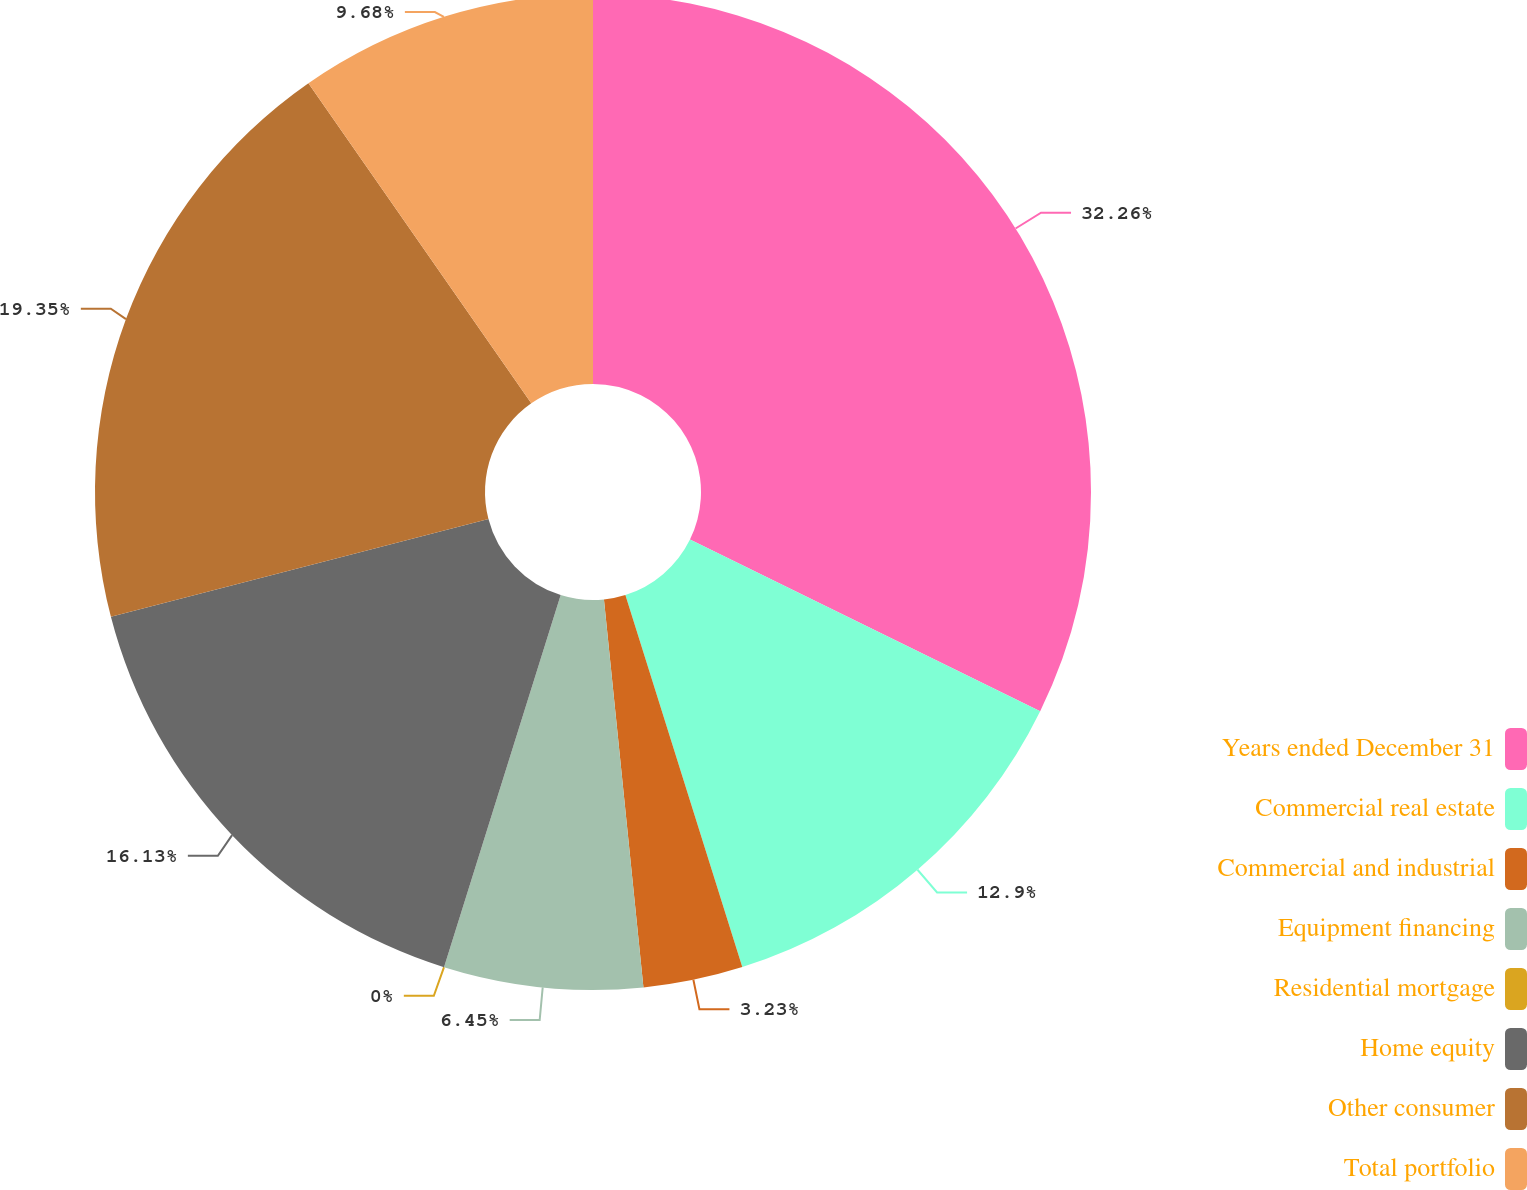Convert chart to OTSL. <chart><loc_0><loc_0><loc_500><loc_500><pie_chart><fcel>Years ended December 31<fcel>Commercial real estate<fcel>Commercial and industrial<fcel>Equipment financing<fcel>Residential mortgage<fcel>Home equity<fcel>Other consumer<fcel>Total portfolio<nl><fcel>32.25%<fcel>12.9%<fcel>3.23%<fcel>6.45%<fcel>0.0%<fcel>16.13%<fcel>19.35%<fcel>9.68%<nl></chart> 